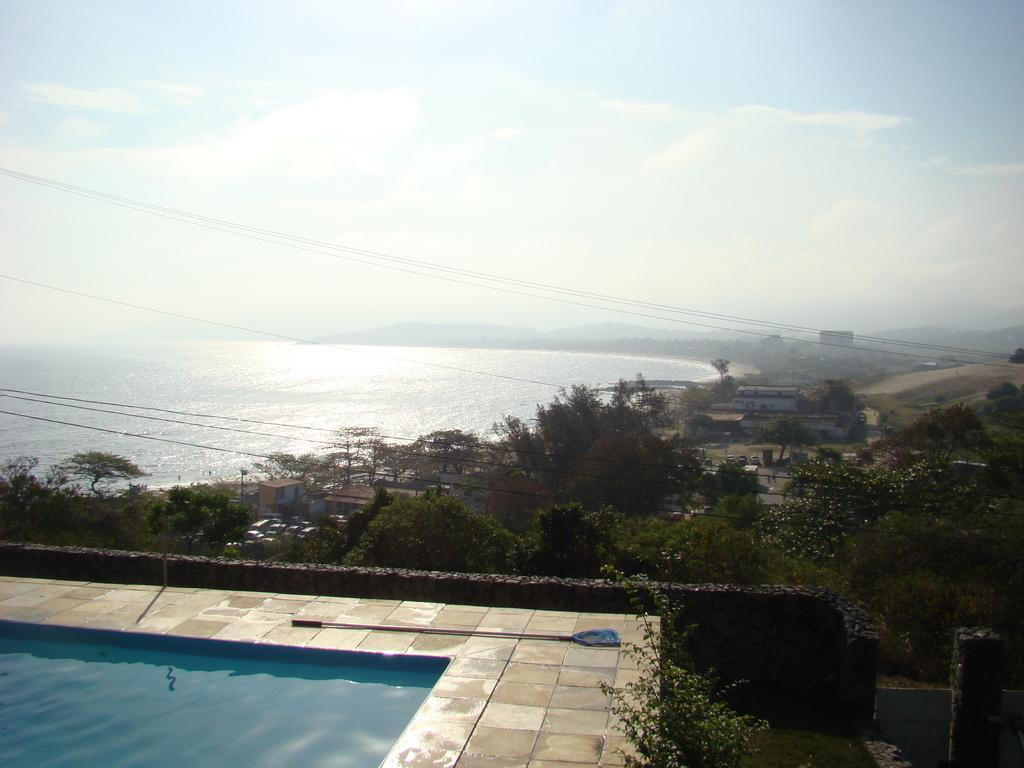What body of water is present in the image? There is a swimming pool in the image. What type of vegetation can be seen in the image? There are green trees in the image. What can be seen in the distance behind the swimming pool? There is a sea in the background of the image. What is visible at the top of the image? The sky is visible at the top of the image. Where is the swing located in the image? There is no swing present in the image. Can you describe the cat's behavior in the image? There is no cat present in the image. 